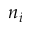Convert formula to latex. <formula><loc_0><loc_0><loc_500><loc_500>n _ { i }</formula> 